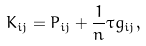<formula> <loc_0><loc_0><loc_500><loc_500>K _ { i j } = P _ { i j } + \frac { 1 } { n } \tau g _ { i j } ,</formula> 